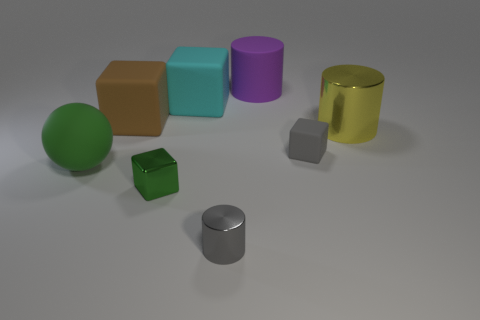Is the number of metal objects behind the big green matte ball greater than the number of tiny brown metal blocks?
Ensure brevity in your answer.  Yes. Is there any other thing that has the same color as the small metal cylinder?
Make the answer very short. Yes. What shape is the big rubber object that is on the right side of the tiny shiny thing that is on the right side of the metallic block?
Give a very brief answer. Cylinder. Are there more tiny red rubber blocks than large cylinders?
Your answer should be compact. No. What number of objects are behind the tiny gray cube and in front of the green ball?
Offer a terse response. 0. How many large rubber balls are to the right of the metallic cylinder behind the gray block?
Offer a terse response. 0. What number of objects are either rubber things behind the green rubber sphere or cylinders right of the tiny rubber cube?
Keep it short and to the point. 5. There is a small green thing that is the same shape as the large cyan thing; what is it made of?
Your answer should be compact. Metal. What number of things are either big objects that are in front of the cyan matte thing or purple spheres?
Make the answer very short. 3. There is a tiny object that is made of the same material as the large green object; what is its shape?
Provide a short and direct response. Cube. 